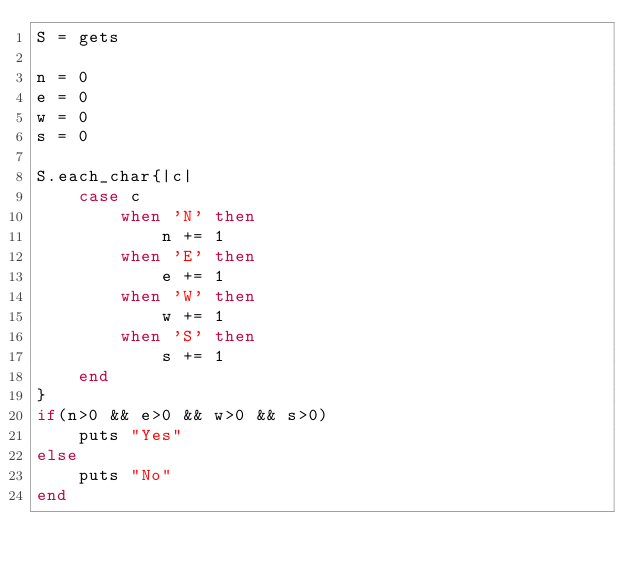Convert code to text. <code><loc_0><loc_0><loc_500><loc_500><_Ruby_>S = gets

n = 0
e = 0
w = 0
s = 0

S.each_char{|c|
	case c
		when 'N' then
			n += 1
		when 'E' then
			e += 1
		when 'W' then
			w += 1
		when 'S' then
			s += 1
	end
}
if(n>0 && e>0 && w>0 && s>0)
	puts "Yes"
else
	puts "No"
end</code> 